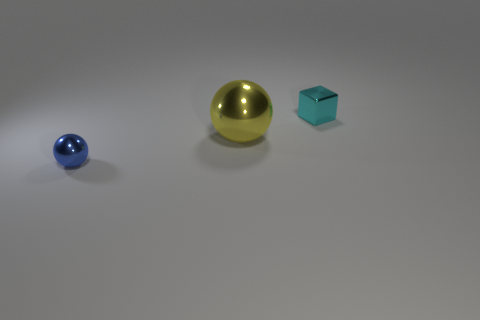How many things are big green matte cylinders or cyan cubes to the right of the large object?
Provide a short and direct response. 1. Are there any other things that have the same material as the blue object?
Give a very brief answer. Yes. What material is the large ball?
Your answer should be very brief. Metal. Does the cyan block have the same material as the tiny blue sphere?
Offer a terse response. Yes. How many metallic things are cyan things or large yellow things?
Give a very brief answer. 2. What is the shape of the metallic object that is in front of the big yellow metal object?
Provide a succinct answer. Sphere. The yellow sphere that is made of the same material as the tiny cyan cube is what size?
Keep it short and to the point. Large. The metallic thing that is behind the small blue metal sphere and to the left of the tiny metallic block has what shape?
Keep it short and to the point. Sphere. There is a small shiny thing to the left of the cyan block; does it have the same color as the small shiny cube?
Give a very brief answer. No. There is a thing that is behind the big metal object; is it the same shape as the small thing that is to the left of the small cyan shiny thing?
Give a very brief answer. No. 